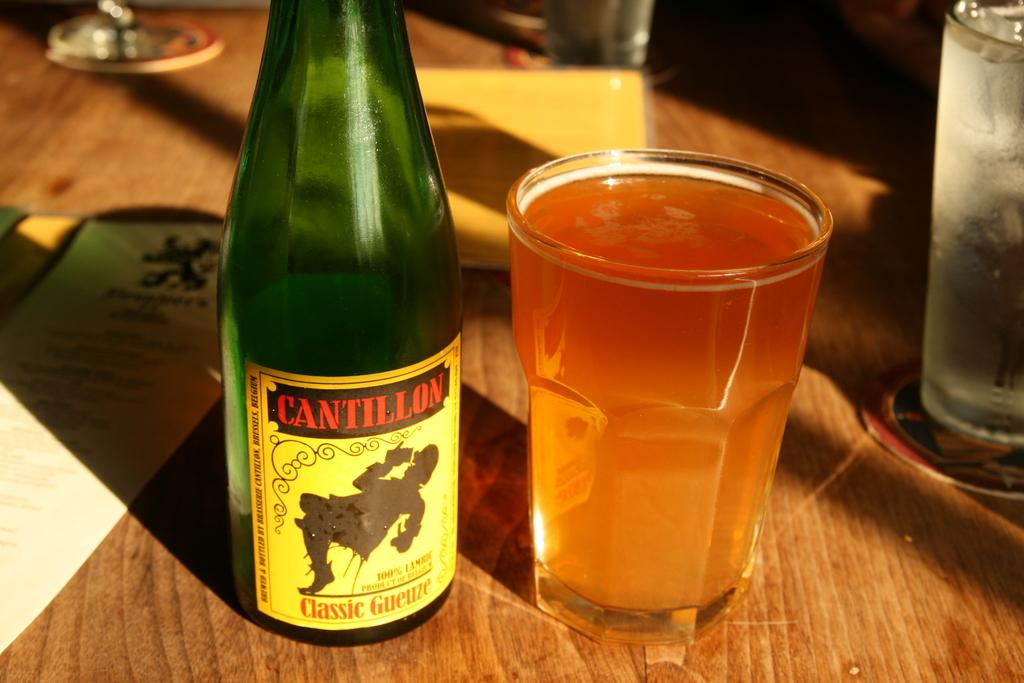Provide a one-sentence caption for the provided image. Bottle of Cantillon next to a full cup of beer on a table. 